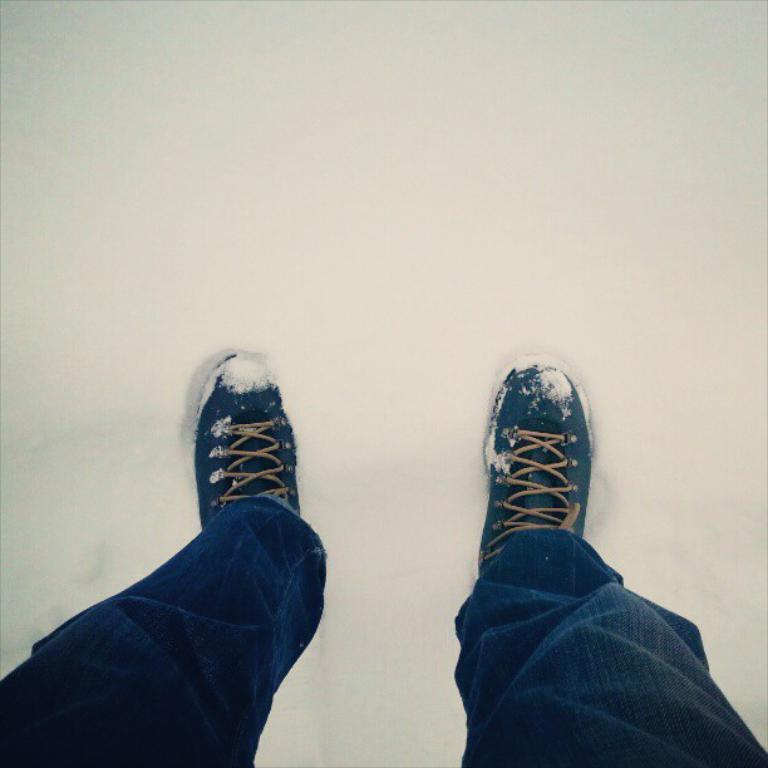What body part can be seen in the image? There are legs visible in the image. What type of clothing is the person wearing on their legs? The person is wearing blue jeans. What type of footwear is the person wearing? The person is wearing shoes. Can you see any baskets attached to the person's legs in the image? There are no baskets visible in the image. 